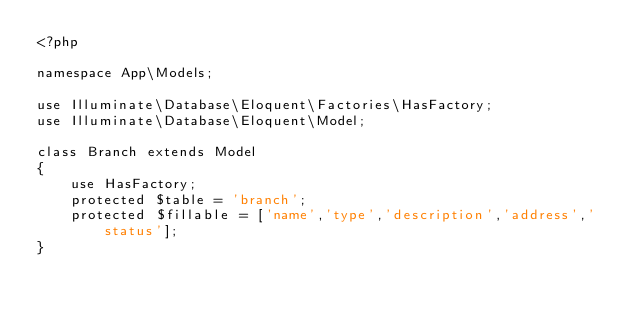<code> <loc_0><loc_0><loc_500><loc_500><_PHP_><?php

namespace App\Models;

use Illuminate\Database\Eloquent\Factories\HasFactory;
use Illuminate\Database\Eloquent\Model;

class Branch extends Model
{
    use HasFactory;
    protected $table = 'branch';
    protected $fillable = ['name','type','description','address','status'];
}
</code> 